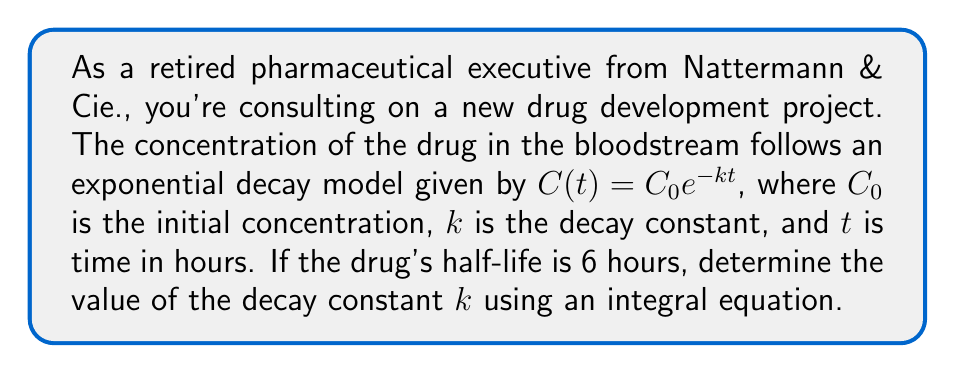Give your solution to this math problem. To solve this problem, we'll follow these steps:

1) The half-life is the time it takes for the concentration to reduce to half of its initial value. We know this is 6 hours, so:

   $C(6) = \frac{1}{2}C_0$

2) Substituting this into our model equation:

   $\frac{1}{2}C_0 = C_0e^{-k(6)}$

3) Simplify by dividing both sides by $C_0$:

   $\frac{1}{2} = e^{-6k}$

4) Take the natural logarithm of both sides:

   $\ln(\frac{1}{2}) = -6k$

5) Solve for $k$:

   $k = -\frac{\ln(\frac{1}{2})}{6} = \frac{\ln(2)}{6}$

6) To express this as an integral equation, we can use the definition of the decay constant in terms of the drug elimination rate:

   $k = -\frac{1}{C_0} \frac{dC}{dt}$

7) Rearranging and integrating both sides from $t=0$ to $t=6$ (the half-life):

   $\int_0^6 \frac{dC}{C} = -k \int_0^6 dt$

8) Solving the integral:

   $[\ln(C)]_0^6 = -k[t]_0^6$

   $\ln(C(6)) - \ln(C_0) = -6k$

   $\ln(\frac{C(6)}{C_0}) = -6k$

9) Since $C(6) = \frac{1}{2}C_0$, we have:

   $\ln(\frac{1}{2}) = -6k$

10) Solving for $k$:

    $k = -\frac{\ln(\frac{1}{2})}{6} = \frac{\ln(2)}{6}$

This is the same result we obtained earlier, confirming our solution.
Answer: $k = \frac{\ln(2)}{6} \approx 0.1155$ hour$^{-1}$ 